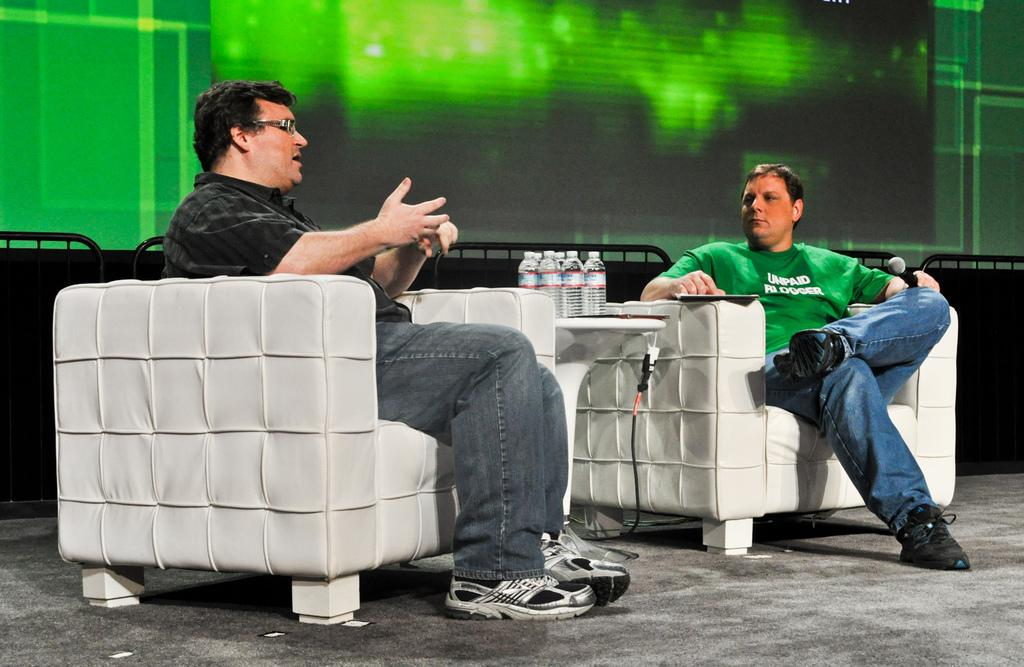What are the people in the image doing? The people in the image are sitting on chairs. What objects can be seen on the table in the image? There are bottles on a table in the image. What color is the background of the image? The background of the image is green. What type of waste can be seen in the image? There is no waste present in the image. How does the image start? The image does not have a beginning or end; it is a static representation. 